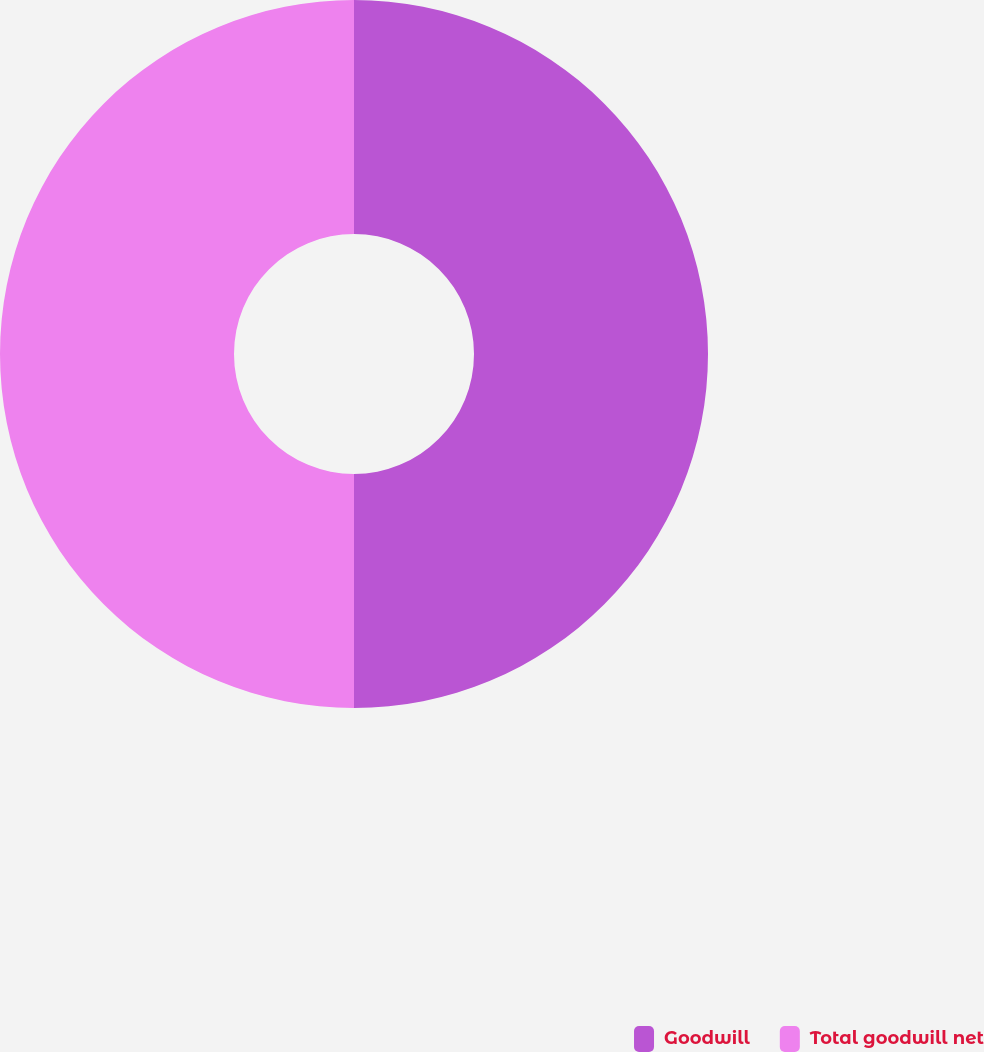<chart> <loc_0><loc_0><loc_500><loc_500><pie_chart><fcel>Goodwill<fcel>Total goodwill net<nl><fcel>50.0%<fcel>50.0%<nl></chart> 